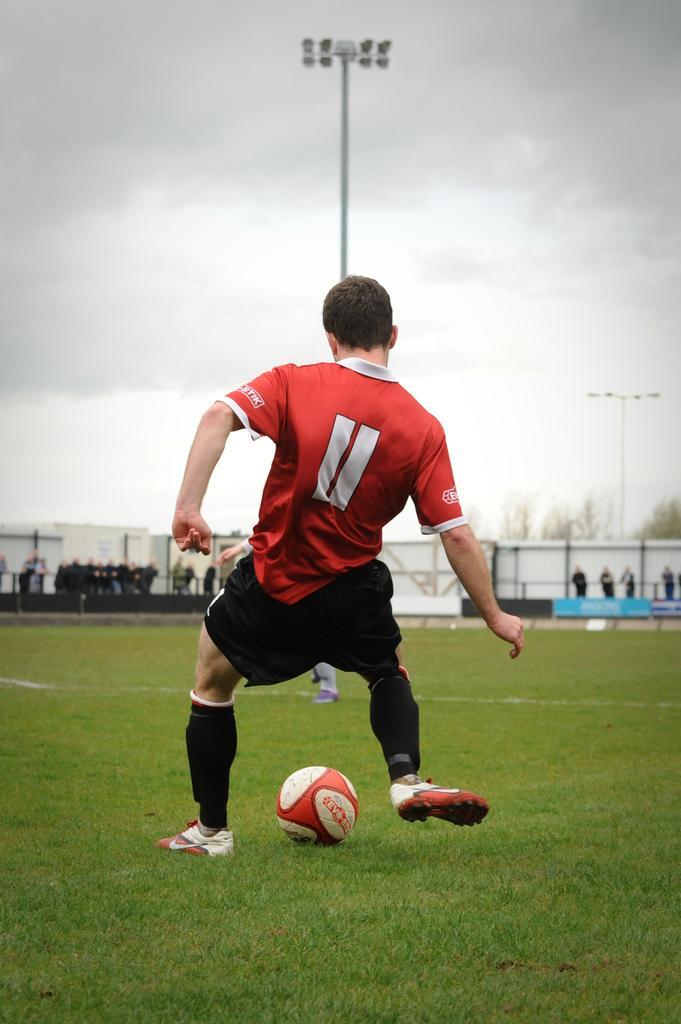Please provide a concise description of this image. The man in red T-shirt is kicking the ball which is in red and white color. I think he is playing football. At the bottom of the picture, we see grass. There are people standing in the background. We see a white color board behind them, there are trees and buildings in the background, We even see street lights. At the top of the picture, we see the sky. 